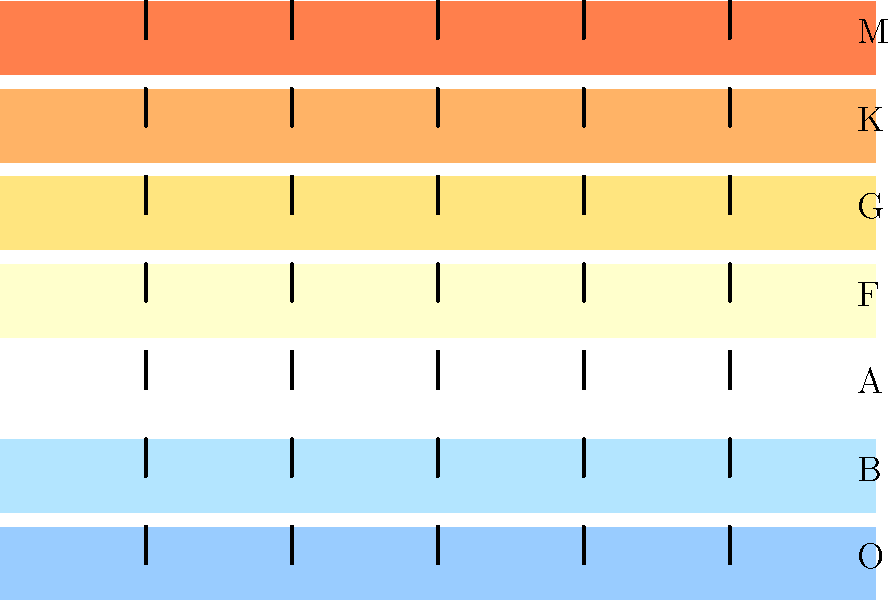In this spectrum diagram of different star types, which class of stars would likely have the strongest hydrogen absorption lines, and why is this significant for audio engineering in terms of frequency analysis? To answer this question, let's break it down step-by-step:

1. The spectrum shown represents different classes of stars, from O (hottest) to M (coolest).

2. Hydrogen absorption lines are strongest in A-type stars. This is because:
   a. O and B stars are too hot, causing hydrogen to be mostly ionized.
   b. F, G, K, and M stars are too cool, resulting in weaker hydrogen lines.

3. A-type stars have a temperature range (7,500-10,000 K) that's optimal for producing strong hydrogen absorption lines, particularly the Balmer series.

4. In audio engineering terms, this phenomenon is analogous to frequency analysis:
   a. The star's spectrum is like an audio frequency spectrum.
   b. Absorption lines are similar to notches or dips in an audio spectrum.

5. The strength of absorption lines in A-type stars is comparable to pronounced frequency dips in audio:
   a. Just as A-type stars have strong, clear hydrogen lines, certain audio sources might have characteristic frequency notches.
   b. Identifying these "spectral signatures" is crucial in both astronomy and audio engineering.

6. For an audio engineer, this concept relates to:
   a. Equalizing: Identifying and adjusting specific frequencies.
   b. Room acoustics: Analyzing and treating room modes (resonant frequencies).
   c. Sound design: Creating or modifying audio "spectral signatures".

7. The ability to identify and analyze these spectral features is crucial in both fields:
   a. In astronomy, for classifying stars and understanding their composition.
   b. In audio, for precise sound manipulation and quality control.
Answer: A-type stars; strongest hydrogen lines relate to identifying and analyzing characteristic frequency patterns in audio spectra. 